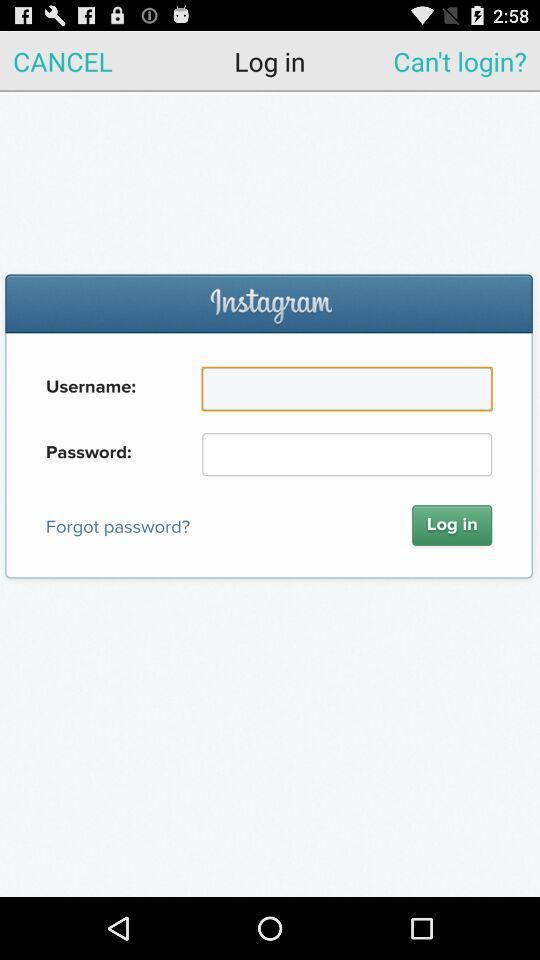Through what application can we log in? You can log in through "Instagram". 